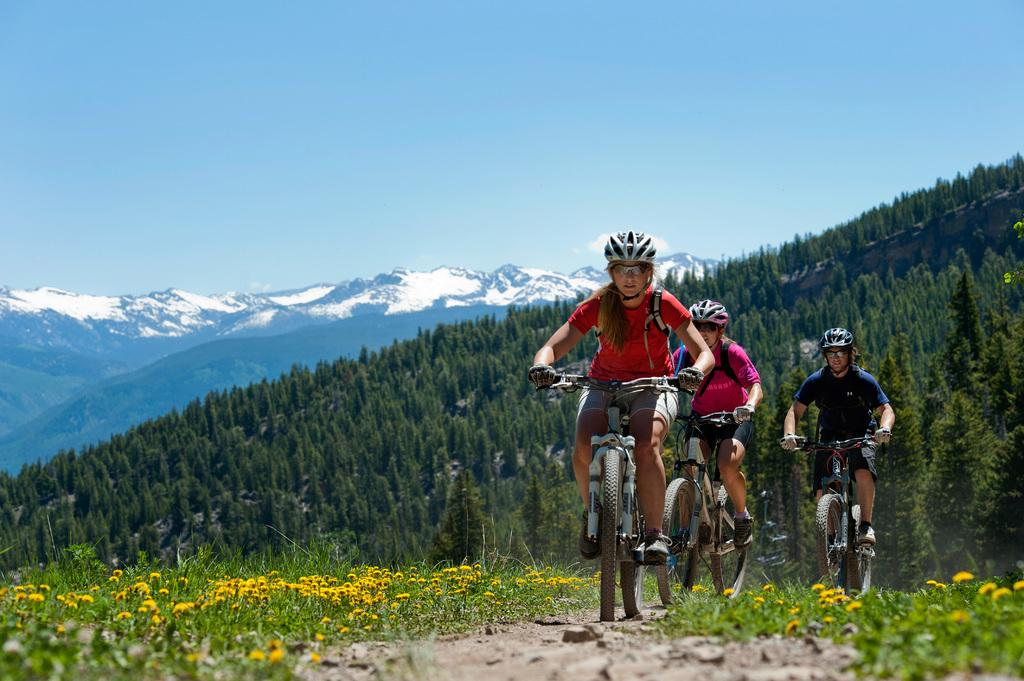How many people are in the image? There are three people in the image. What are the people doing in the image? The people are riding bicycles. What safety precaution are the people taking while riding bicycles? The people are wearing helmets. What type of vegetation can be seen in the image? There are flowers, plants, grass, and trees in the image. What is visible in the background of the image? There are trees, a mountain, and the sky visible in the background of the image. Where is the drain located in the image? There is no drain present in the image. What type of basket is being used by the people in the image? The people are riding bicycles, not carrying baskets, in the image. 